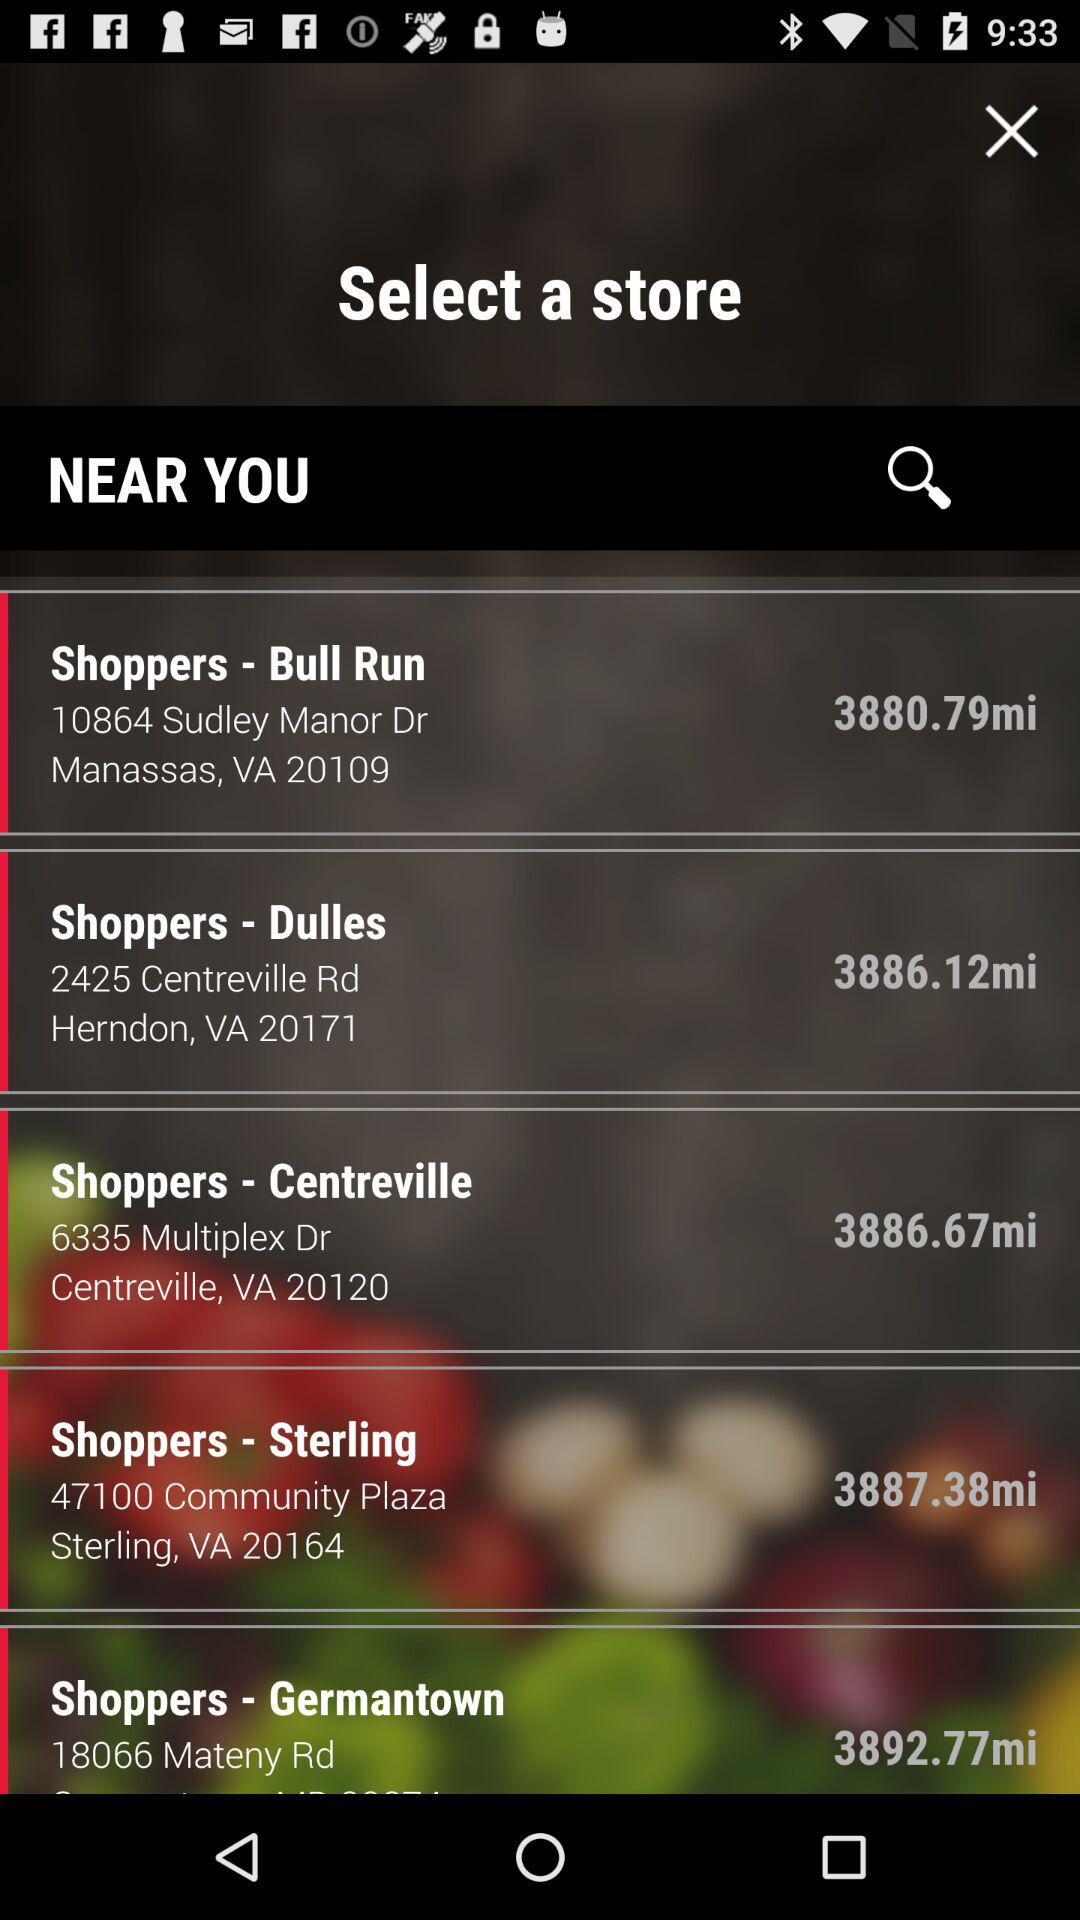Where is "Shoppers - Dulles" located? "Shoppers - Dulles" is located at 2425 Centreville Rd, Herndon, VA 2017. 